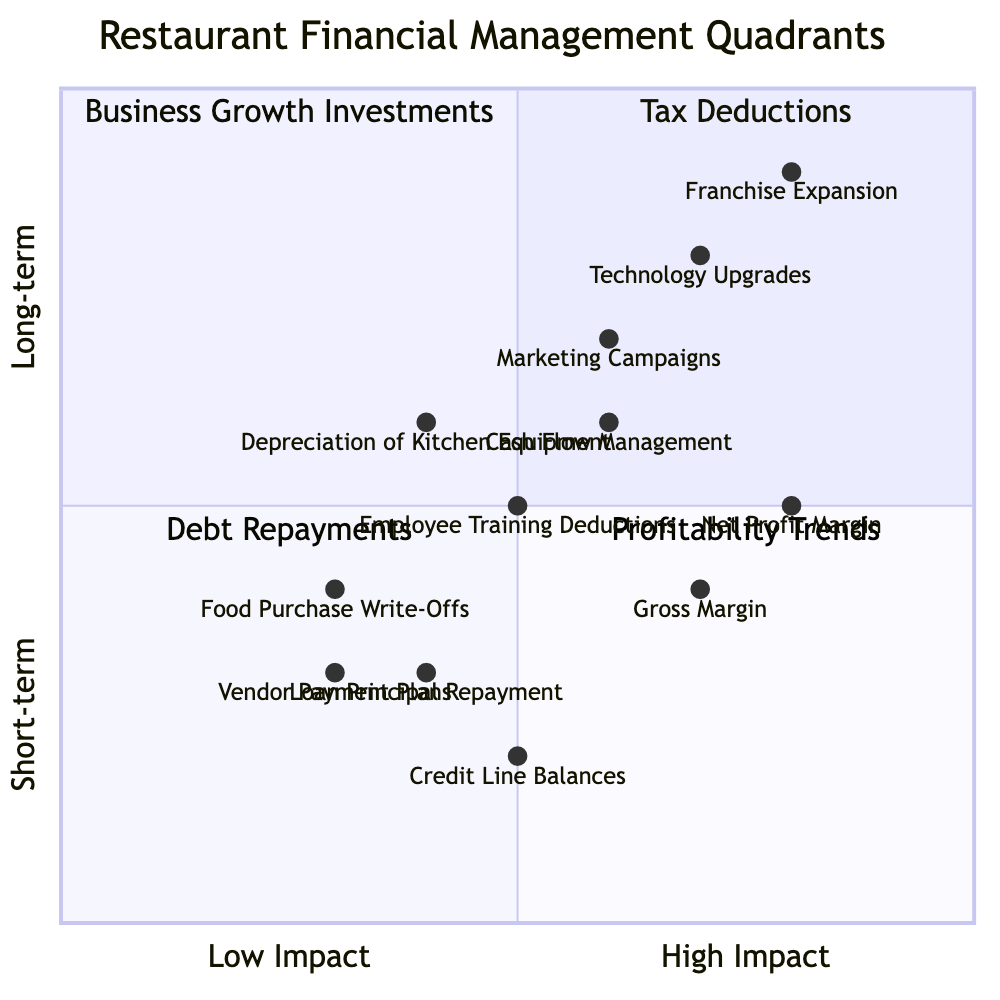What are the elements in the Tax Deductions quadrant? The Tax Deductions quadrant contains three elements: Food Purchase Write-Offs, Depreciation of Kitchen Equipment, and Employee Training Deductions.
Answer: Food Purchase Write-Offs, Depreciation of Kitchen Equipment, Employee Training Deductions Which element in the Business Growth Investments quadrant has the highest impact? Considering the coordinates, Franchise Expansion has the coordinates [0.8, 0.9], making it the furthest to the upper right, indicating the highest impact.
Answer: Franchise Expansion How many elements are in the Debt Repayments quadrant? There are three elements listed under Debt Repayments: Loan Principal Repayment, Credit Line Balances, and Vendor Payment Plans. Thus, the count is three.
Answer: 3 Which Profitability Trends element is positioned closest to the center? The element Cash Flow Management has the coordinates [0.6, 0.6], which are closer to the center compared to the others in the Profitability Trends quadrant.
Answer: Cash Flow Management What is the relationship between Marketing Campaigns and Technology Upgrades? Both elements belong to the Business Growth Investments quadrant, and Marketing Campaigns is located at [0.6, 0.7] while Technology Upgrades is at [0.7, 0.8]. Technology Upgrades is positioned higher, indicating a focus on long-term growth.
Answer: Higher impact for Technology Upgrades Which Debt Repayments element is positioned highest on the vertical axis? Credit Line Balances is at [0.5, 0.2], which is the highest in the Debt Repayments quadrant but is the lowest for proximity to the upper quadrant areas; thus, it has the highest vertical position.
Answer: Credit Line Balances What is the average horizontal impact across the Profitability Trends quadrant? The coordinates for Gross Margin, Net Profit Margin, and Cash Flow Management are [0.7, 0.4], [0.8, 0.5], and [0.6, 0.6]. Calculating the average for the horizontal axis (0.7 + 0.8 + 0.6) ÷ 3 = 0.7.
Answer: 0.7 Which element represents the least effective tax deduction? The element Vendor Payment Plans has coordinates [0.3, 0.3], which place it further left and lower in the Tax Deductions quadrant, indicating it's less effective compared to others.
Answer: Vendor Payment Plans What is the overall trend regarding profitability elements? All three elements of Profitability Trends are positioned vertically with 0.4, 0.5, and 0.6 on the vertical axis, showing a trend towards improving profitability over time as you move from Gross Margin to Cash Flow Management.
Answer: Improving profitability trend 